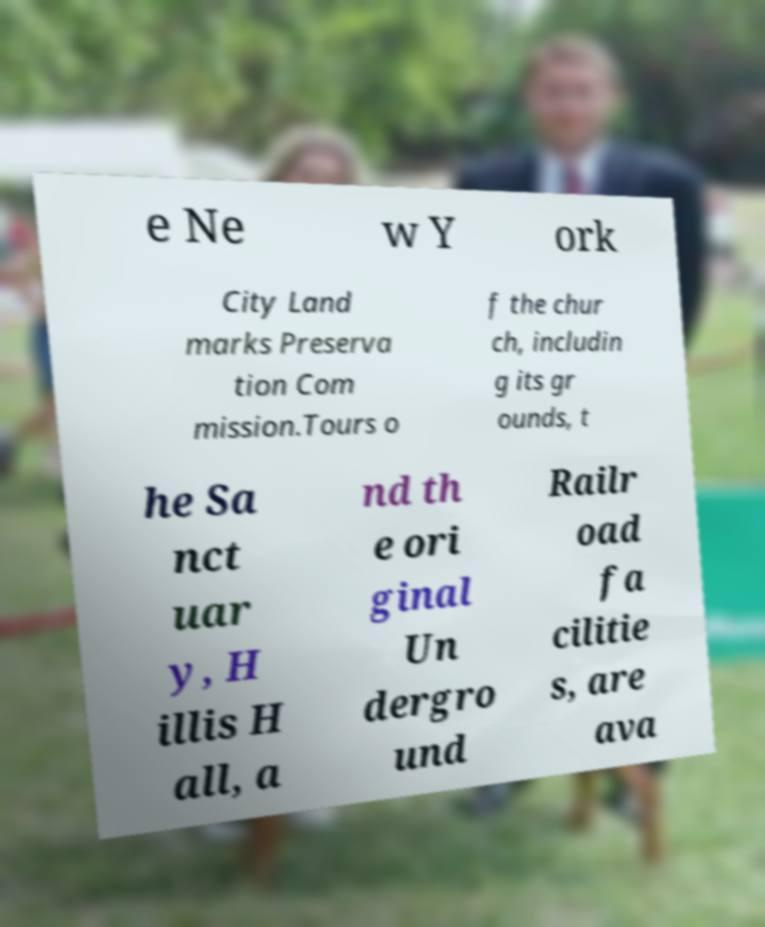Could you assist in decoding the text presented in this image and type it out clearly? e Ne w Y ork City Land marks Preserva tion Com mission.Tours o f the chur ch, includin g its gr ounds, t he Sa nct uar y, H illis H all, a nd th e ori ginal Un dergro und Railr oad fa cilitie s, are ava 